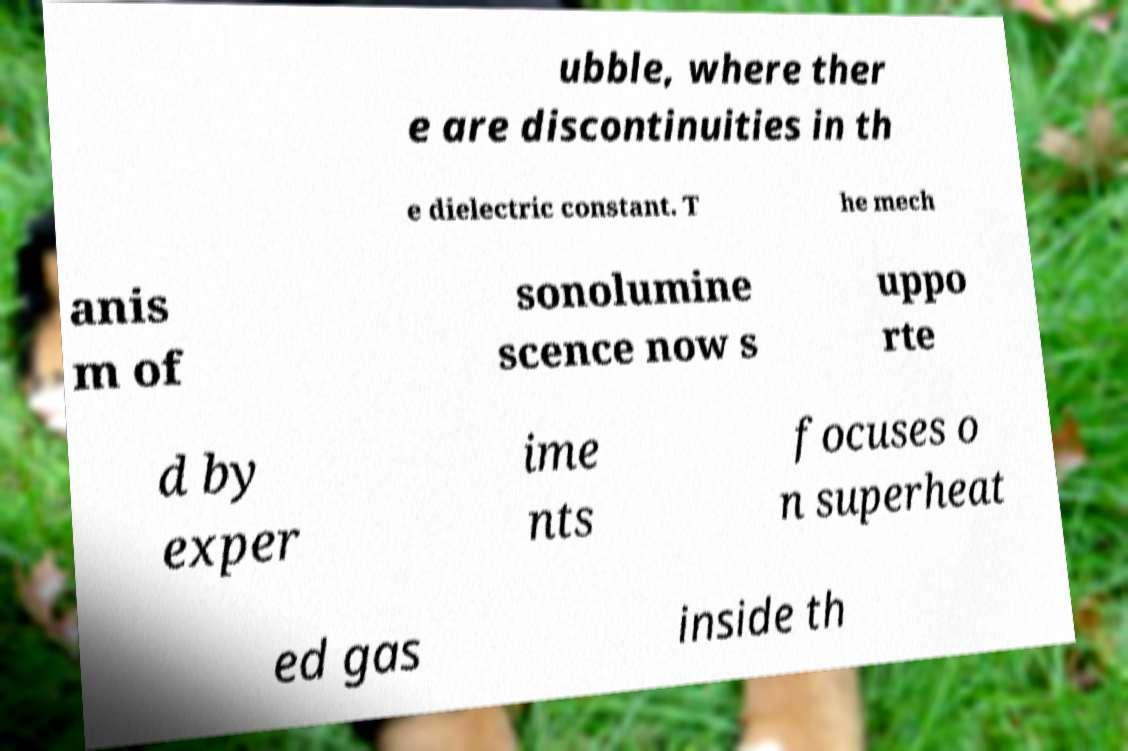For documentation purposes, I need the text within this image transcribed. Could you provide that? ubble, where ther e are discontinuities in th e dielectric constant. T he mech anis m of sonolumine scence now s uppo rte d by exper ime nts focuses o n superheat ed gas inside th 